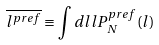<formula> <loc_0><loc_0><loc_500><loc_500>\overline { l ^ { p r e f } } \equiv \int d l l P _ { N } ^ { p r e f } ( l )</formula> 